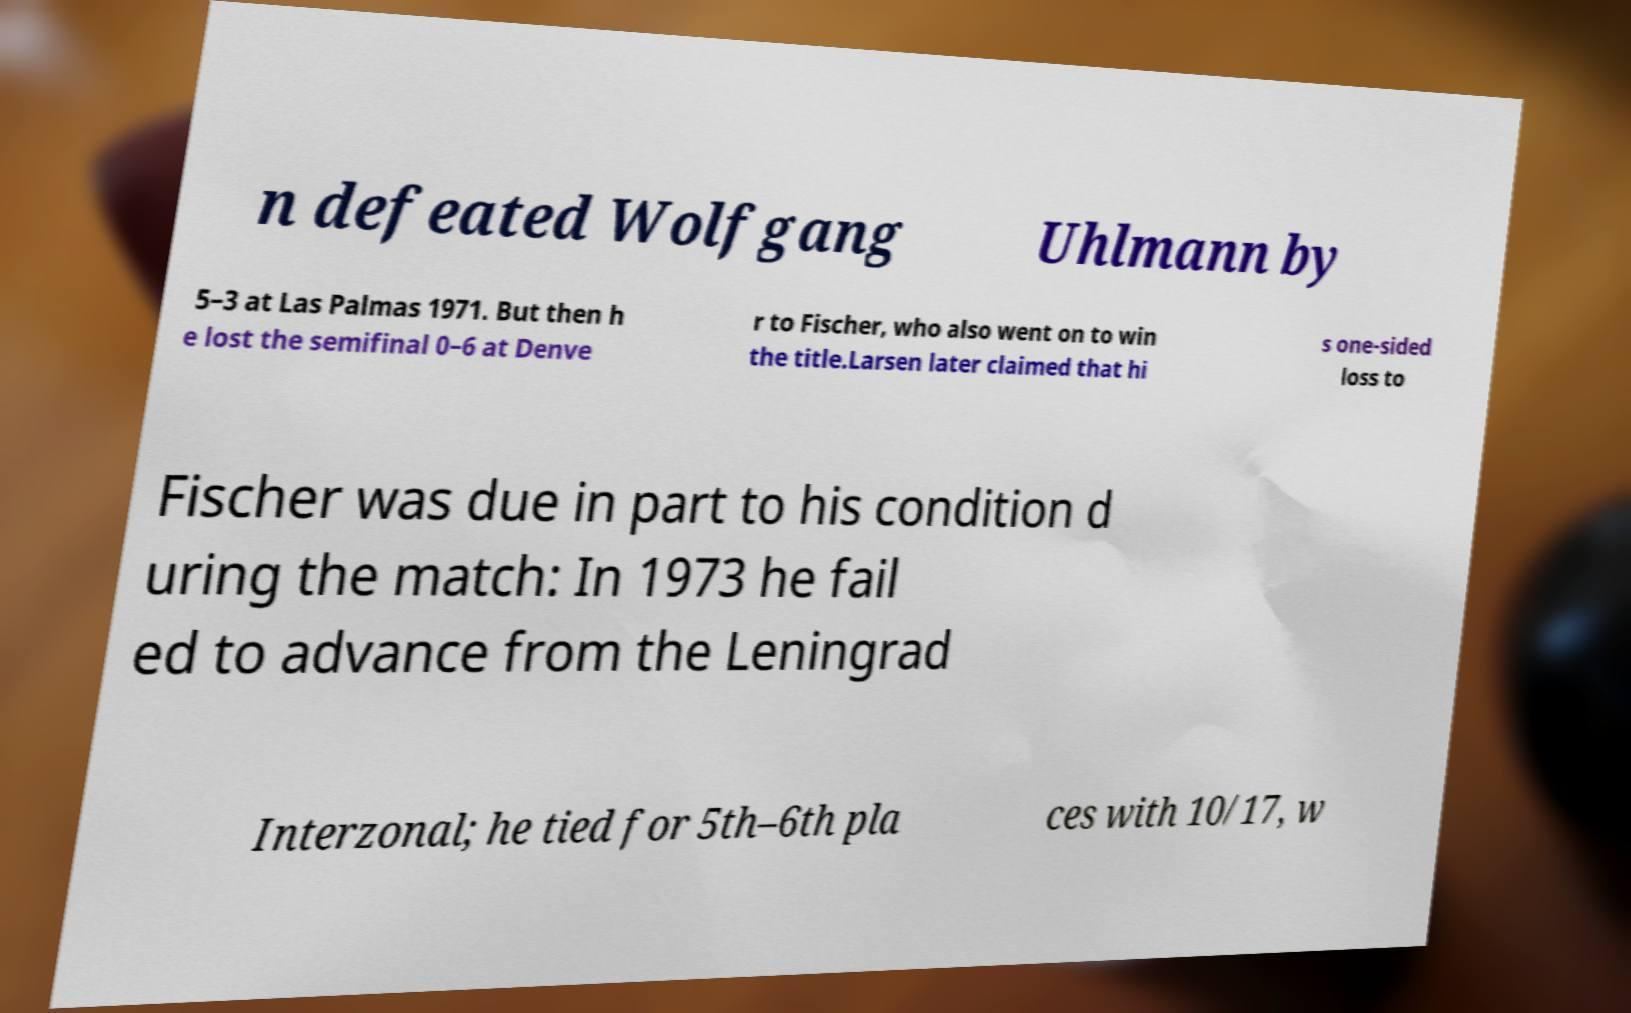Can you read and provide the text displayed in the image?This photo seems to have some interesting text. Can you extract and type it out for me? n defeated Wolfgang Uhlmann by 5–3 at Las Palmas 1971. But then h e lost the semifinal 0–6 at Denve r to Fischer, who also went on to win the title.Larsen later claimed that hi s one-sided loss to Fischer was due in part to his condition d uring the match: In 1973 he fail ed to advance from the Leningrad Interzonal; he tied for 5th–6th pla ces with 10/17, w 